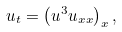<formula> <loc_0><loc_0><loc_500><loc_500>u _ { t } = \left ( u ^ { 3 } u _ { x x } \right ) _ { x } ,</formula> 